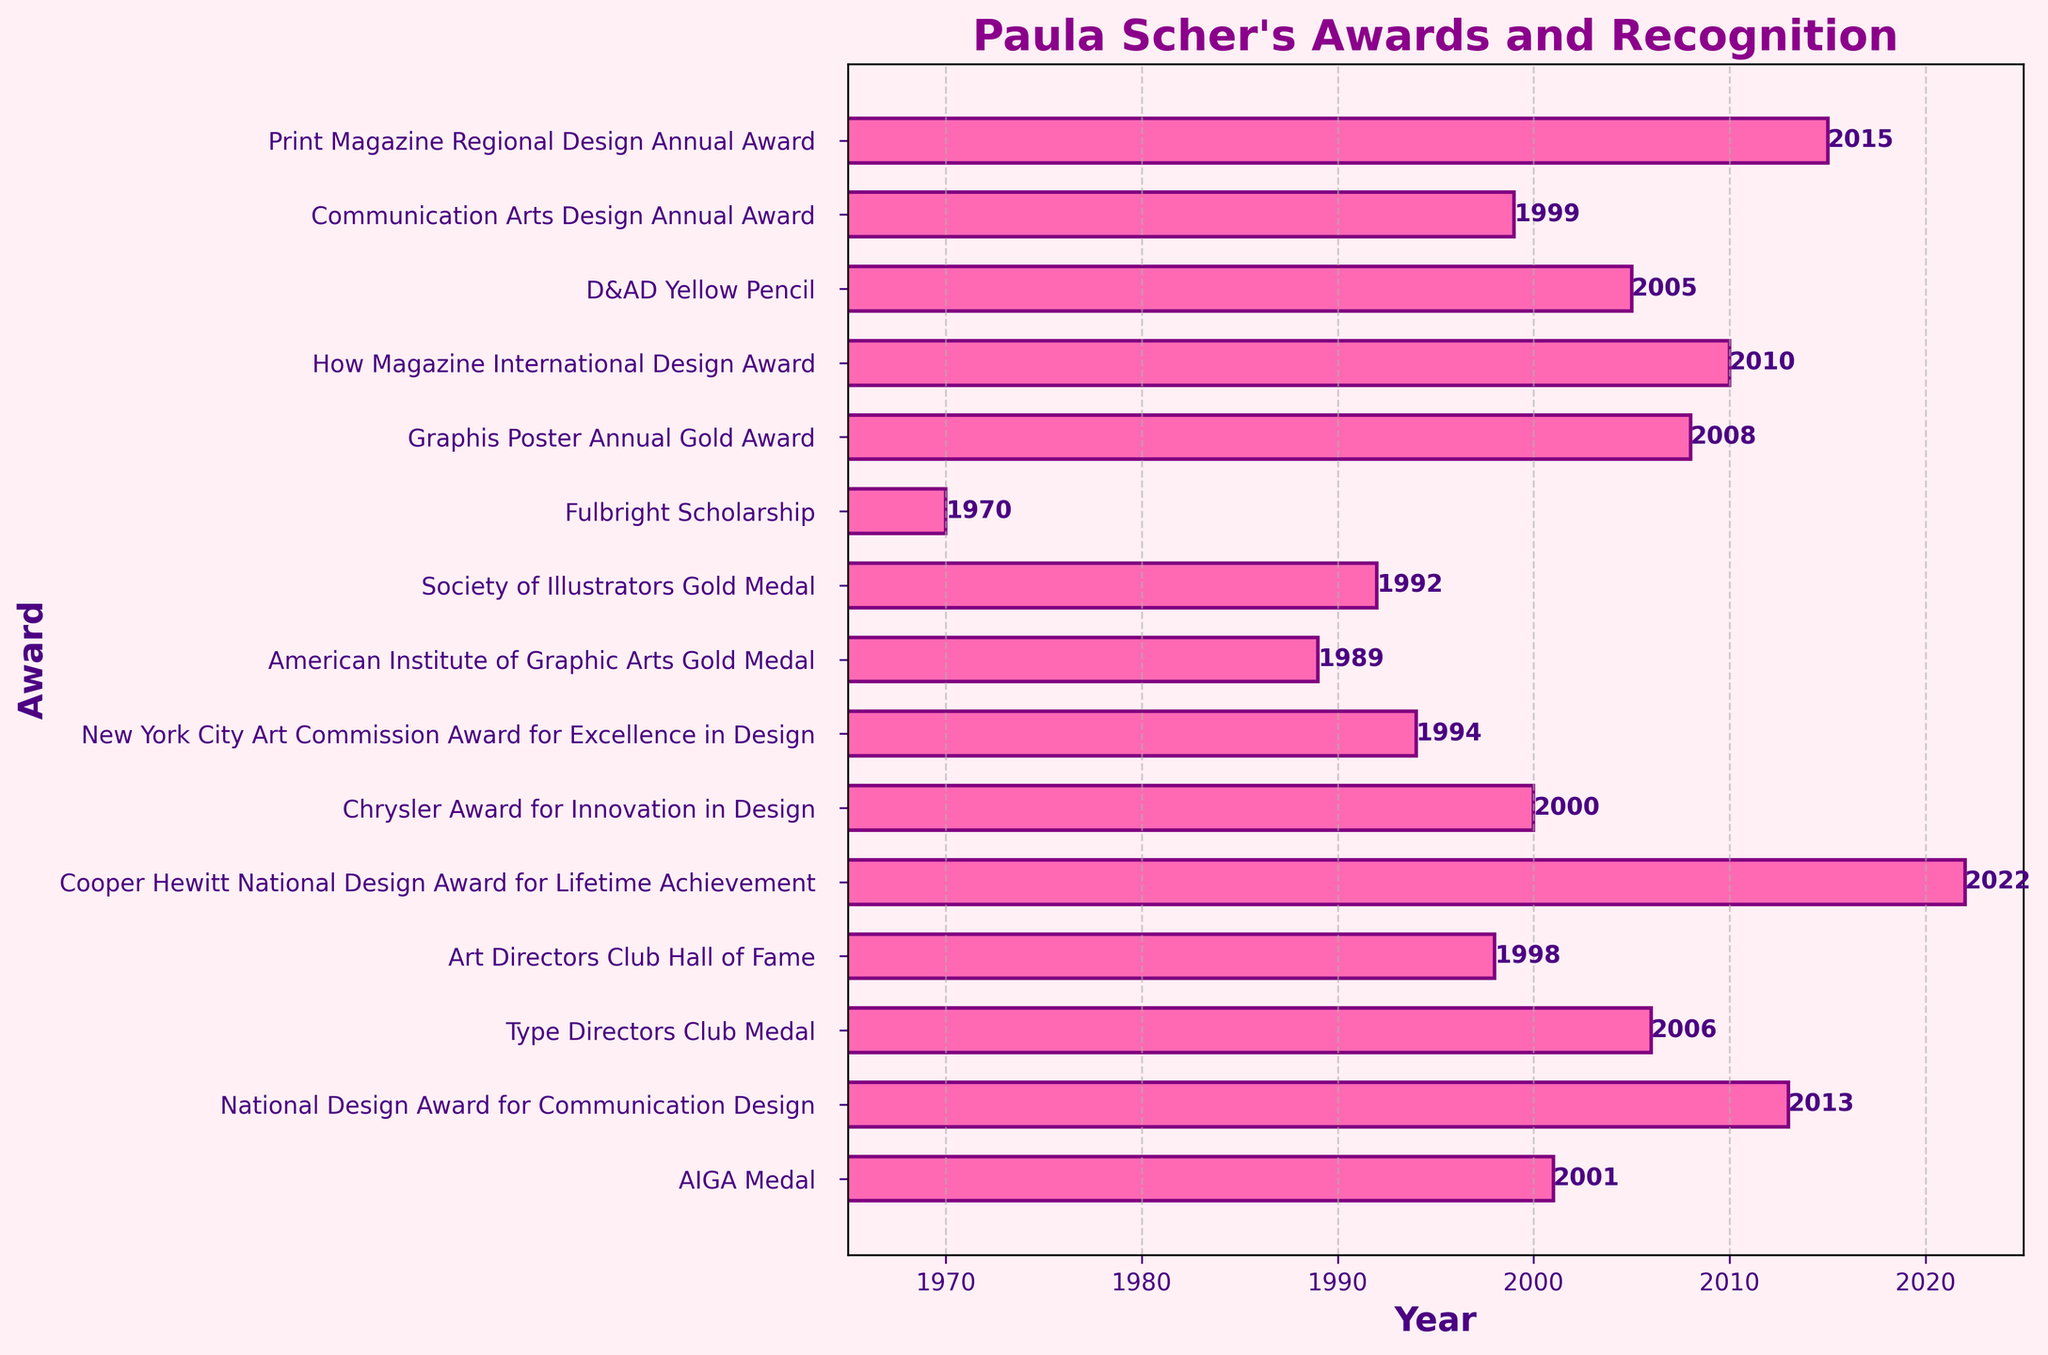Which award did Paula Scher receive in 2001? Look for the bar representing the year 2001 and read the award's name at the corresponding y-axis label.
Answer: AIGA Medal Which was the earliest award received by Paula Scher shown in the chart? Identify the bar with the smallest year value on the x-axis and read the award's name at the corresponding y-axis label.
Answer: Fulbright Scholarship How many years after receiving the American Institute of Graphic Arts Gold Medal did Paula Scher receive the AIGA Medal? Identify the year Paula Scher received both awards: 1989 for the American Institute of Graphic Arts Gold Medal and 2001 for the AIGA Medal. Subtract the earlier year from the later year (2001 - 1989).
Answer: 12 years Which two awards did Paula Scher receive most closely together in terms of years? Compare the x-axis positions of all the bars to find the smallest difference in years between any two consecutive awards. The closest pair are the 1998 Art Directors Club Hall of Fame and the 1999 Communication Arts Design Annual Award.
Answer: Art Directors Club Hall of Fame and Communication Arts Design Annual Award What is the average year in which Paula Scher received her awards? Sum all the years given for each award and divide by the number of awards: (1970 + 1989 + 1992 + 1994 + 1998 + 1999 + 2000 + 2001 + 2005 + 2006 + 2008 + 2010 + 2013 + 2015 + 2022) / 15 = 2003.4
Answer: 2003.4 Which year did Paula Scher receive an award for lifetime achievement? Look for the bar labeled with a description mentioning "lifetime achievement" and check the corresponding year.
Answer: 2022 Which award has the darkest color among all the bars? Observe the color of all the bars and identify the one with the darkest shade. Since all bars are the same color, there is no variation to compare.
Answer: None Which awards did Paula Scher receive between 2000 and 2010? Identify the bars falling within the year range of 2000 to 2010 and read their corresponding labels: 2000 (Chrysler Award for Innovation in Design), 2001 (AIGA Medal), 2005 (D&AD Yellow Pencil), 2006 (Type Directors Club Medal), 2008 (Graphis Poster Annual Gold Award), 2010 (How Magazine International Design Award).
Answer: Chrysler Award for Innovation in Design, AIGA Medal, D&AD Yellow Pencil, Type Directors Club Medal, Graphis Poster Annual Gold Award, How Magazine International Design Award Which award did Paula Scher receive most recently? Find the bar with the highest year value on the x-axis and read the corresponding award's name.
Answer: Cooper Hewitt National Design Award for Lifetime Achievement 